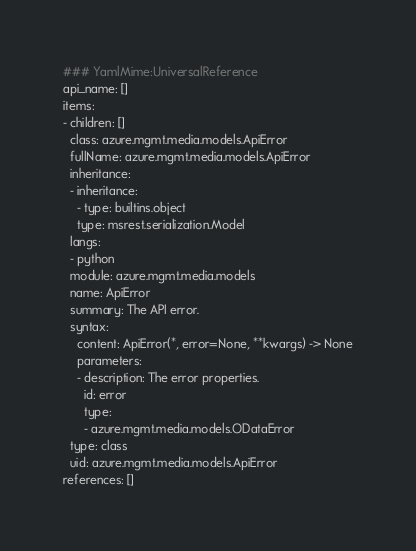Convert code to text. <code><loc_0><loc_0><loc_500><loc_500><_YAML_>### YamlMime:UniversalReference
api_name: []
items:
- children: []
  class: azure.mgmt.media.models.ApiError
  fullName: azure.mgmt.media.models.ApiError
  inheritance:
  - inheritance:
    - type: builtins.object
    type: msrest.serialization.Model
  langs:
  - python
  module: azure.mgmt.media.models
  name: ApiError
  summary: The API error.
  syntax:
    content: ApiError(*, error=None, **kwargs) -> None
    parameters:
    - description: The error properties.
      id: error
      type:
      - azure.mgmt.media.models.ODataError
  type: class
  uid: azure.mgmt.media.models.ApiError
references: []
</code> 